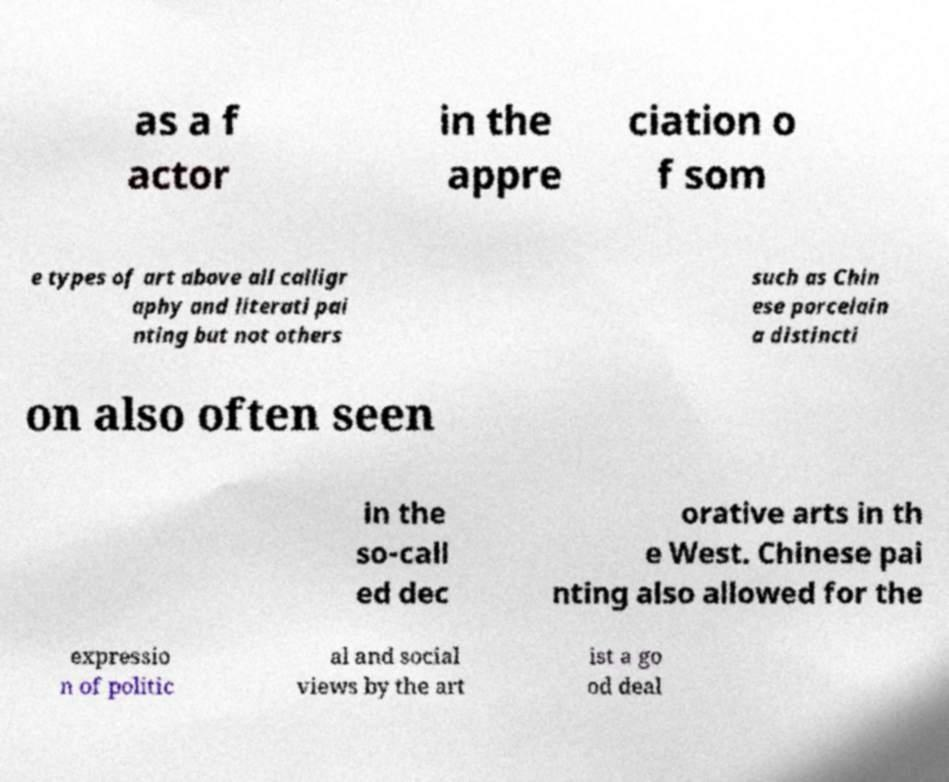Can you accurately transcribe the text from the provided image for me? as a f actor in the appre ciation o f som e types of art above all calligr aphy and literati pai nting but not others such as Chin ese porcelain a distincti on also often seen in the so-call ed dec orative arts in th e West. Chinese pai nting also allowed for the expressio n of politic al and social views by the art ist a go od deal 